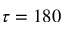Convert formula to latex. <formula><loc_0><loc_0><loc_500><loc_500>\tau = 1 8 0</formula> 